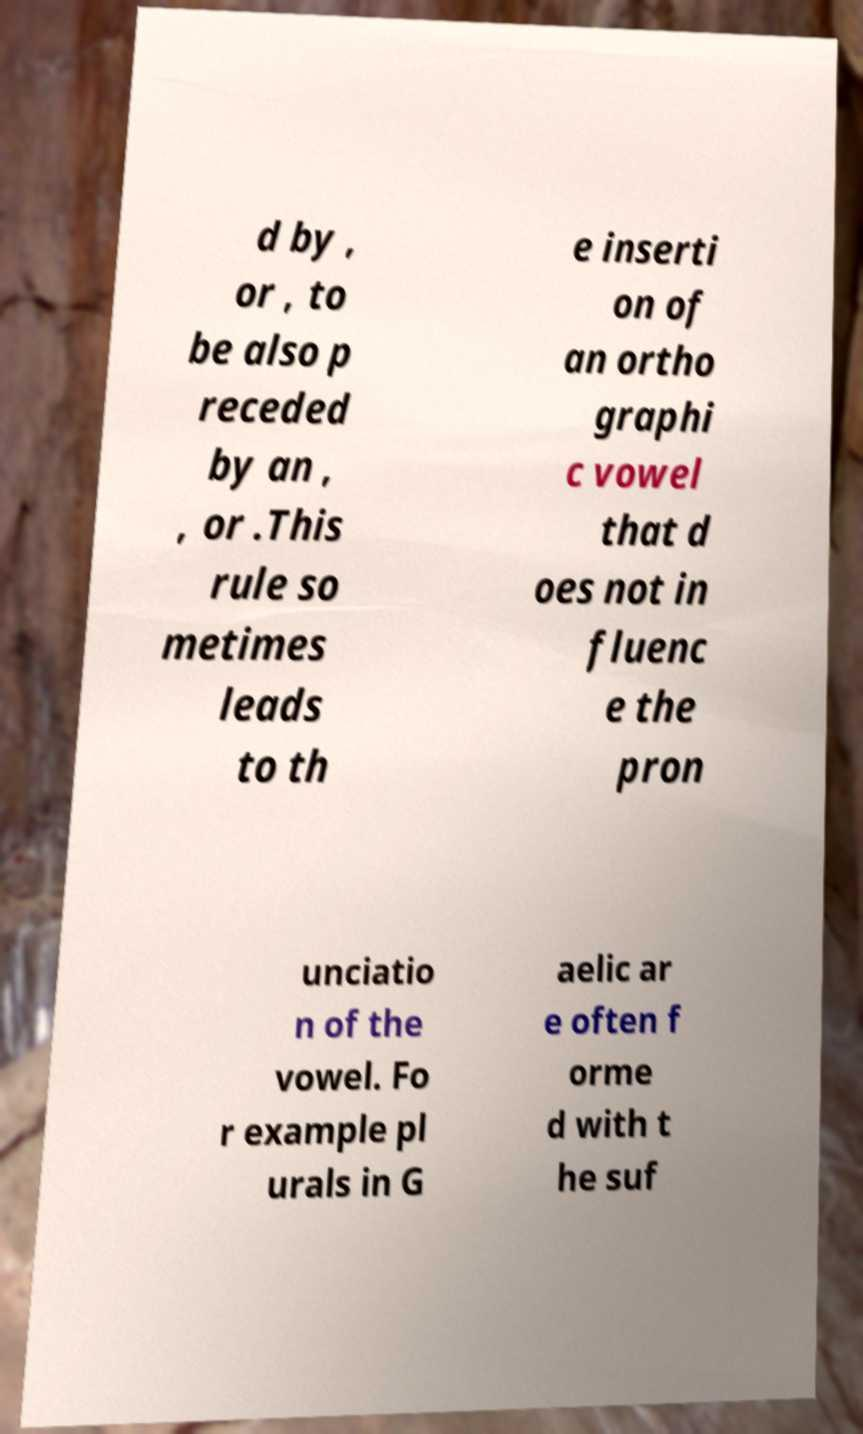What messages or text are displayed in this image? I need them in a readable, typed format. d by , or , to be also p receded by an , , or .This rule so metimes leads to th e inserti on of an ortho graphi c vowel that d oes not in fluenc e the pron unciatio n of the vowel. Fo r example pl urals in G aelic ar e often f orme d with t he suf 